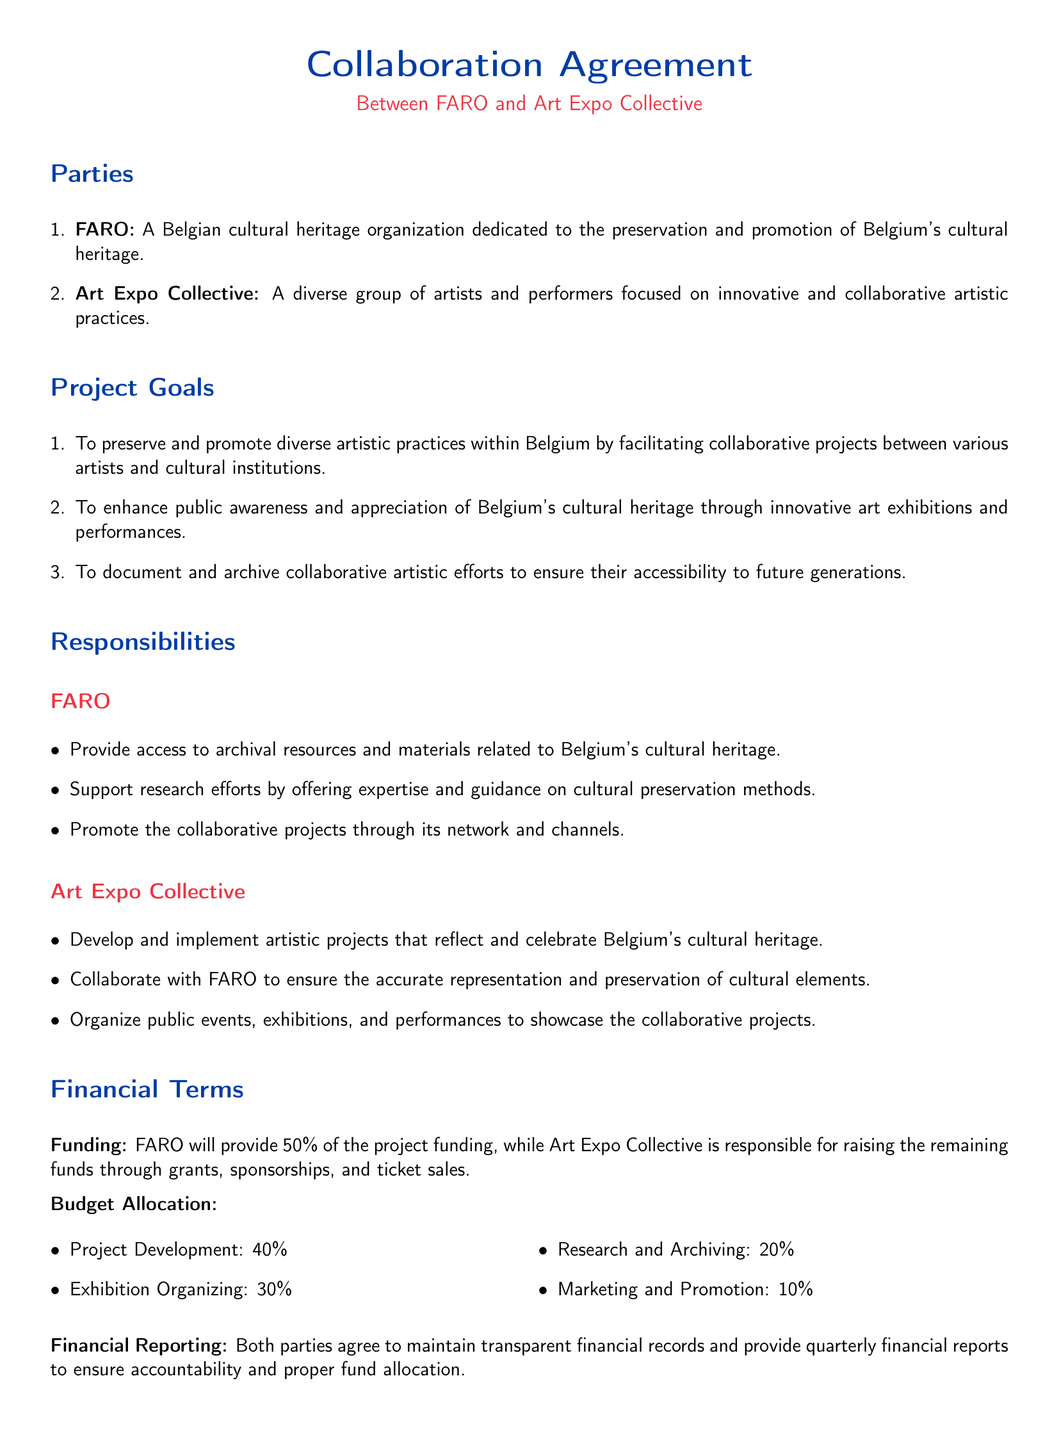What are the parties involved in this agreement? The agreement lists FARO and Art Expo Collective as the parties involved.
Answer: FARO and Art Expo Collective What is the primary goal of the project? The document states the project's goals including preserving and promoting diverse artistic practices.
Answer: Preserve and promote diverse artistic practices How much funding will FARO provide? The document specifies that FARO will provide 50% of the project funding.
Answer: 50% What percentage of the budget is allocated for Project Development? The budget allocation section clearly indicates the percentages for each category.
Answer: 40% Who is responsible for raising the remaining funds? The agreement details the responsibilities of both parties regarding funding sources.
Answer: Art Expo Collective What is the financial reporting frequency required by this agreement? The document outlines the expectation for financial reporting.
Answer: Quarterly What type of events will the Art Expo Collective organize? The Art Expo Collective's responsibilities include the organization of specific types of events.
Answer: Public events, exhibitions, and performances Under which law will this agreement be governed? The governing law section specifies the jurisdiction for the agreement.
Answer: Laws of Belgium 